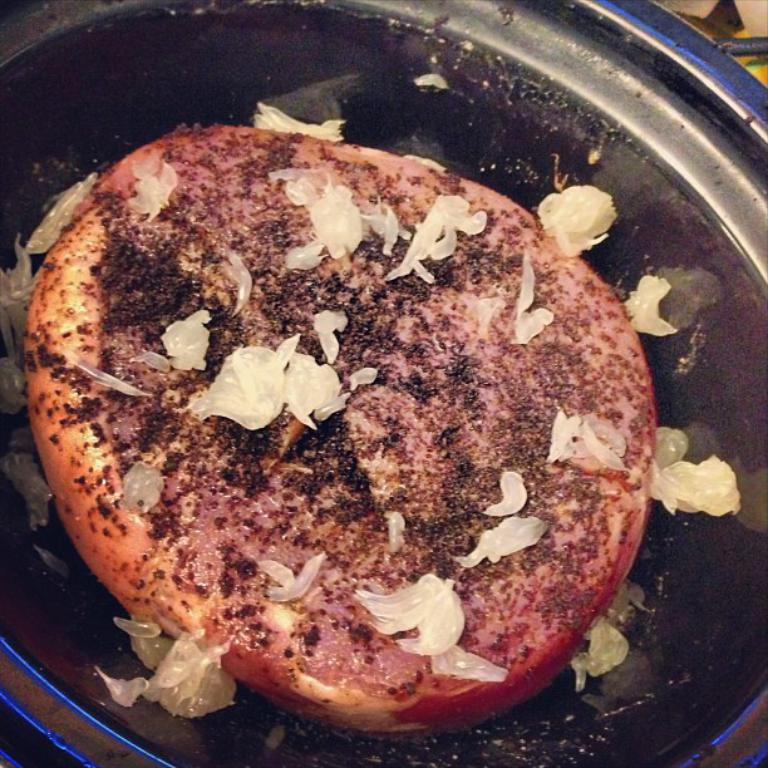What is the main subject of the image? There is a food item in a bowl in the image. Can you describe the food item in the bowl? Unfortunately, the image is not clear enough to describe the food item in the top right corner. How many apples are visible in the image? There are no apples present in the image. What type of boot is being worn by the laborer in the image? There is no laborer or boot present in the image. 